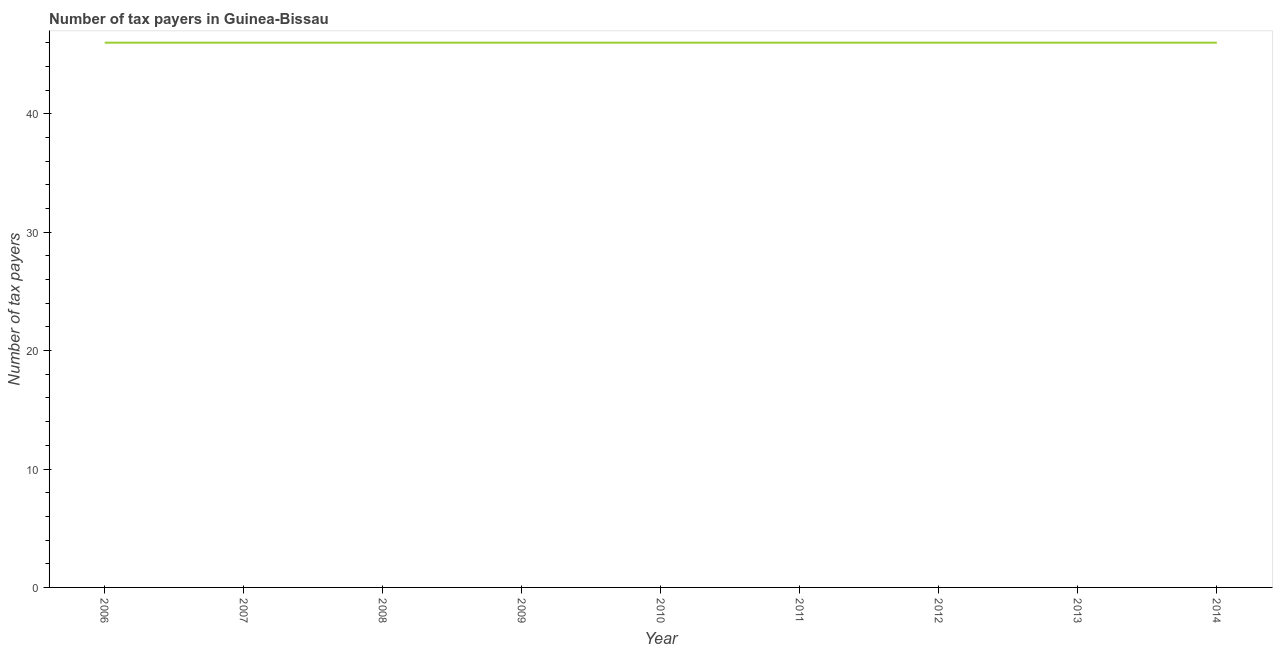What is the number of tax payers in 2014?
Ensure brevity in your answer.  46. Across all years, what is the maximum number of tax payers?
Provide a succinct answer. 46. Across all years, what is the minimum number of tax payers?
Offer a terse response. 46. What is the sum of the number of tax payers?
Provide a short and direct response. 414. What is the difference between the number of tax payers in 2010 and 2013?
Ensure brevity in your answer.  0. What is the average number of tax payers per year?
Your response must be concise. 46. In how many years, is the number of tax payers greater than 4 ?
Offer a very short reply. 9. Do a majority of the years between 2010 and 2006 (inclusive) have number of tax payers greater than 22 ?
Offer a very short reply. Yes. What is the ratio of the number of tax payers in 2006 to that in 2009?
Your answer should be very brief. 1. Is the number of tax payers in 2006 less than that in 2013?
Provide a succinct answer. No. Is the difference between the number of tax payers in 2007 and 2010 greater than the difference between any two years?
Offer a very short reply. Yes. What is the difference between the highest and the second highest number of tax payers?
Make the answer very short. 0. Is the sum of the number of tax payers in 2013 and 2014 greater than the maximum number of tax payers across all years?
Keep it short and to the point. Yes. What is the difference between the highest and the lowest number of tax payers?
Give a very brief answer. 0. How many years are there in the graph?
Make the answer very short. 9. What is the difference between two consecutive major ticks on the Y-axis?
Your response must be concise. 10. Are the values on the major ticks of Y-axis written in scientific E-notation?
Your answer should be compact. No. Does the graph contain grids?
Give a very brief answer. No. What is the title of the graph?
Make the answer very short. Number of tax payers in Guinea-Bissau. What is the label or title of the Y-axis?
Your answer should be very brief. Number of tax payers. What is the Number of tax payers in 2006?
Make the answer very short. 46. What is the Number of tax payers in 2007?
Your answer should be very brief. 46. What is the Number of tax payers of 2013?
Ensure brevity in your answer.  46. What is the difference between the Number of tax payers in 2006 and 2007?
Give a very brief answer. 0. What is the difference between the Number of tax payers in 2006 and 2008?
Offer a very short reply. 0. What is the difference between the Number of tax payers in 2006 and 2010?
Make the answer very short. 0. What is the difference between the Number of tax payers in 2006 and 2011?
Make the answer very short. 0. What is the difference between the Number of tax payers in 2006 and 2012?
Offer a very short reply. 0. What is the difference between the Number of tax payers in 2007 and 2008?
Keep it short and to the point. 0. What is the difference between the Number of tax payers in 2007 and 2010?
Provide a short and direct response. 0. What is the difference between the Number of tax payers in 2007 and 2011?
Your answer should be compact. 0. What is the difference between the Number of tax payers in 2007 and 2012?
Provide a succinct answer. 0. What is the difference between the Number of tax payers in 2008 and 2010?
Ensure brevity in your answer.  0. What is the difference between the Number of tax payers in 2008 and 2011?
Your response must be concise. 0. What is the difference between the Number of tax payers in 2008 and 2013?
Your response must be concise. 0. What is the difference between the Number of tax payers in 2009 and 2010?
Offer a very short reply. 0. What is the difference between the Number of tax payers in 2009 and 2013?
Ensure brevity in your answer.  0. What is the difference between the Number of tax payers in 2009 and 2014?
Offer a very short reply. 0. What is the difference between the Number of tax payers in 2010 and 2012?
Ensure brevity in your answer.  0. What is the difference between the Number of tax payers in 2010 and 2013?
Provide a succinct answer. 0. What is the difference between the Number of tax payers in 2010 and 2014?
Offer a terse response. 0. What is the difference between the Number of tax payers in 2011 and 2013?
Ensure brevity in your answer.  0. What is the difference between the Number of tax payers in 2013 and 2014?
Offer a terse response. 0. What is the ratio of the Number of tax payers in 2006 to that in 2007?
Your response must be concise. 1. What is the ratio of the Number of tax payers in 2006 to that in 2009?
Provide a succinct answer. 1. What is the ratio of the Number of tax payers in 2006 to that in 2011?
Keep it short and to the point. 1. What is the ratio of the Number of tax payers in 2006 to that in 2014?
Give a very brief answer. 1. What is the ratio of the Number of tax payers in 2007 to that in 2009?
Make the answer very short. 1. What is the ratio of the Number of tax payers in 2007 to that in 2010?
Provide a short and direct response. 1. What is the ratio of the Number of tax payers in 2007 to that in 2012?
Your response must be concise. 1. What is the ratio of the Number of tax payers in 2007 to that in 2013?
Your response must be concise. 1. What is the ratio of the Number of tax payers in 2008 to that in 2009?
Offer a very short reply. 1. What is the ratio of the Number of tax payers in 2008 to that in 2010?
Make the answer very short. 1. What is the ratio of the Number of tax payers in 2008 to that in 2011?
Your response must be concise. 1. What is the ratio of the Number of tax payers in 2008 to that in 2014?
Offer a very short reply. 1. What is the ratio of the Number of tax payers in 2009 to that in 2014?
Provide a succinct answer. 1. What is the ratio of the Number of tax payers in 2010 to that in 2012?
Offer a terse response. 1. What is the ratio of the Number of tax payers in 2010 to that in 2013?
Ensure brevity in your answer.  1. What is the ratio of the Number of tax payers in 2013 to that in 2014?
Give a very brief answer. 1. 